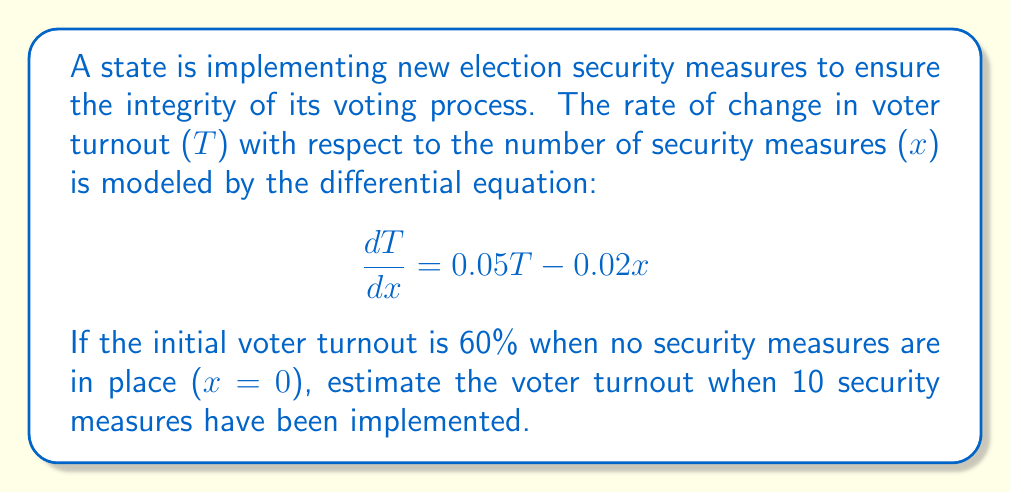Can you answer this question? To solve this problem, we need to use the method for solving first-order linear differential equations.

1) The general form of a first-order linear differential equation is:

   $$\frac{dy}{dx} + P(x)y = Q(x)$$

2) In our case:
   $$\frac{dT}{dx} = 0.05T - 0.02x$$
   $$\frac{dT}{dx} - 0.05T = -0.02x$$

   So, P(x) = -0.05 and Q(x) = -0.02x

3) The integrating factor is:
   $$\mu(x) = e^{\int P(x)dx} = e^{\int -0.05dx} = e^{-0.05x}$$

4) Multiply both sides of the equation by the integrating factor:
   $$e^{-0.05x}\frac{dT}{dx} - 0.05e^{-0.05x}T = -0.02xe^{-0.05x}$$

5) The left side is now the derivative of $e^{-0.05x}T$, so we can write:
   $$\frac{d}{dx}(e^{-0.05x}T) = -0.02xe^{-0.05x}$$

6) Integrate both sides:
   $$e^{-0.05x}T = \int -0.02xe^{-0.05x}dx$$

7) Using integration by parts:
   $$e^{-0.05x}T = -0.02(-20xe^{-0.05x} - 400e^{-0.05x}) + C$$
   $$e^{-0.05x}T = 0.4xe^{-0.05x} + 8e^{-0.05x} + C$$

8) Multiply both sides by $e^{0.05x}$:
   $$T = 0.4x + 8 + Ce^{0.05x}$$

9) Use the initial condition T(0) = 60 to find C:
   $$60 = 0.4(0) + 8 + C$$
   $$C = 52$$

10) The final solution is:
    $$T = 0.4x + 8 + 52e^{0.05x}$$

11) To find T when x = 10:
    $$T(10) = 0.4(10) + 8 + 52e^{0.5}$$
    $$T(10) = 4 + 8 + 52(1.6487)$$
    $$T(10) = 12 + 85.7324 = 97.7324$$

Therefore, the estimated voter turnout when 10 security measures have been implemented is approximately 97.73%.
Answer: The estimated voter turnout when 10 security measures have been implemented is approximately 97.73%. 